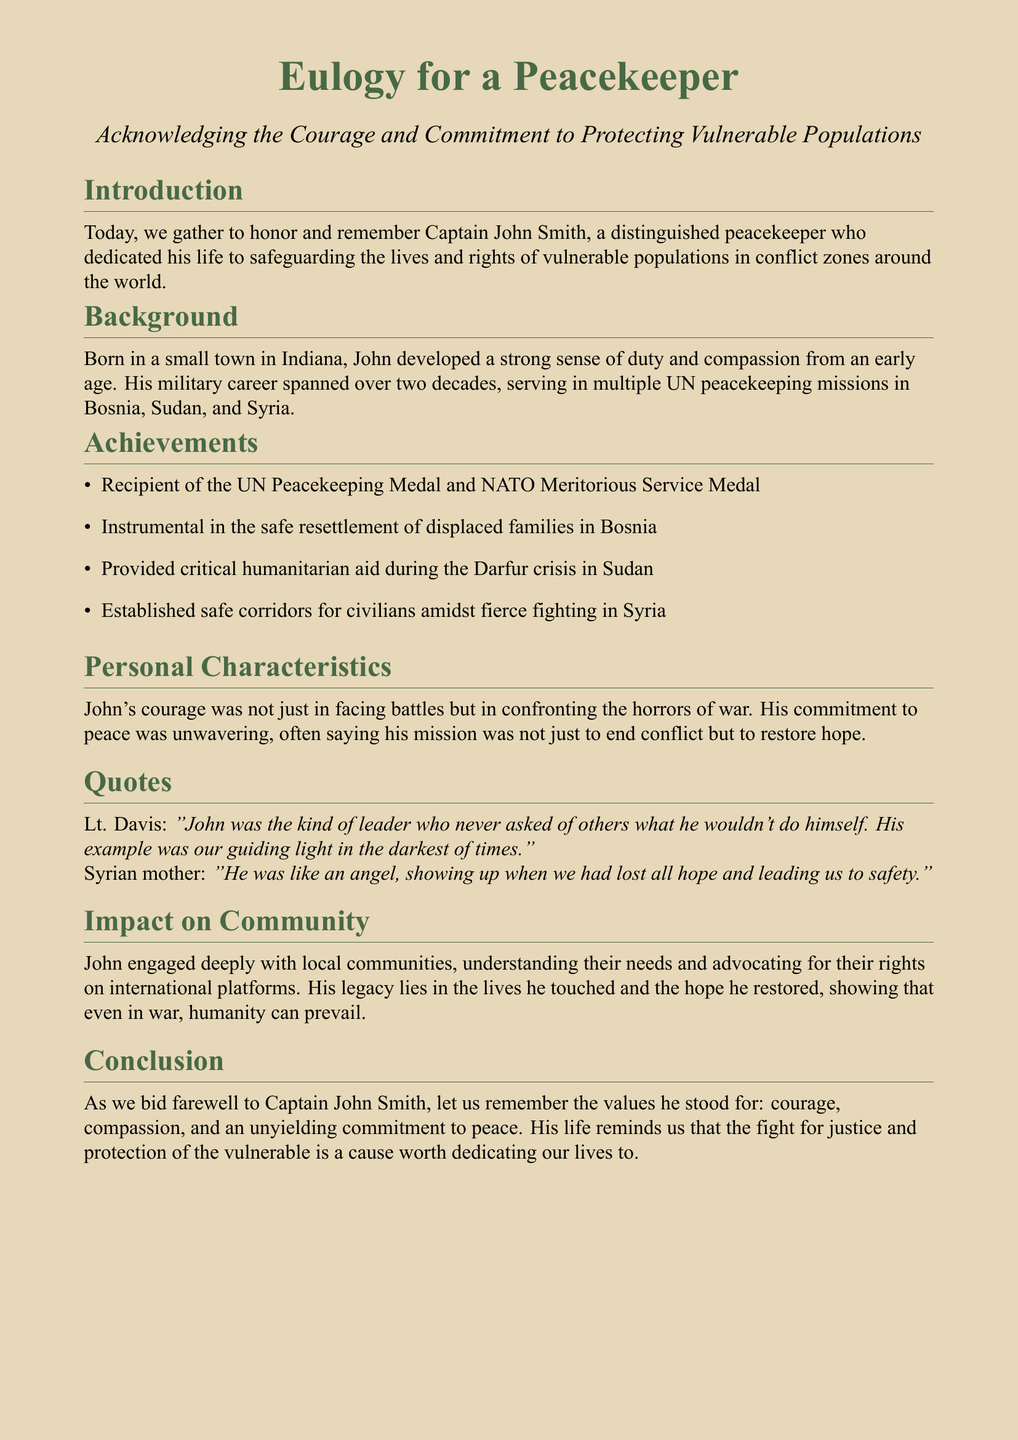What is the name of the peacekeeper being honored? The document states that the peacekeeper being honored is Captain John Smith.
Answer: Captain John Smith In which state was Captain John Smith born? The document mentions that he was born in a small town in Indiana.
Answer: Indiana How many UN peacekeeping missions did he serve in? The document indicates that his military career spanned over two decades and included multiple UN peacekeeping missions, but it does not specify a number.
Answer: Multiple Which award did he receive from the UN? The document lists the UN Peacekeeping Medal as one of the awards he received.
Answer: UN Peacekeeping Medal What was one of John’s achievements in Bosnia? According to the document, he was instrumental in the safe resettlement of displaced families in Bosnia.
Answer: Safe resettlement of displaced families What did John often say his mission was about? The document notes that John often said his mission was to restore hope.
Answer: Restore hope Who described John as "like an angel"? A Syrian mother is quoted in the document describing John with this phrase.
Answer: Syrian mother What quality did Lt. Davis associate with John's leadership? Lt. Davis mentioned that John was the kind of leader who never asked of others what he wouldn't do himself.
Answer: Leading by example What are the three values mentioned in the conclusion associated with John? The document lists courage, compassion, and an unyielding commitment to peace as values associated with John.
Answer: Courage, compassion, commitment to peace 